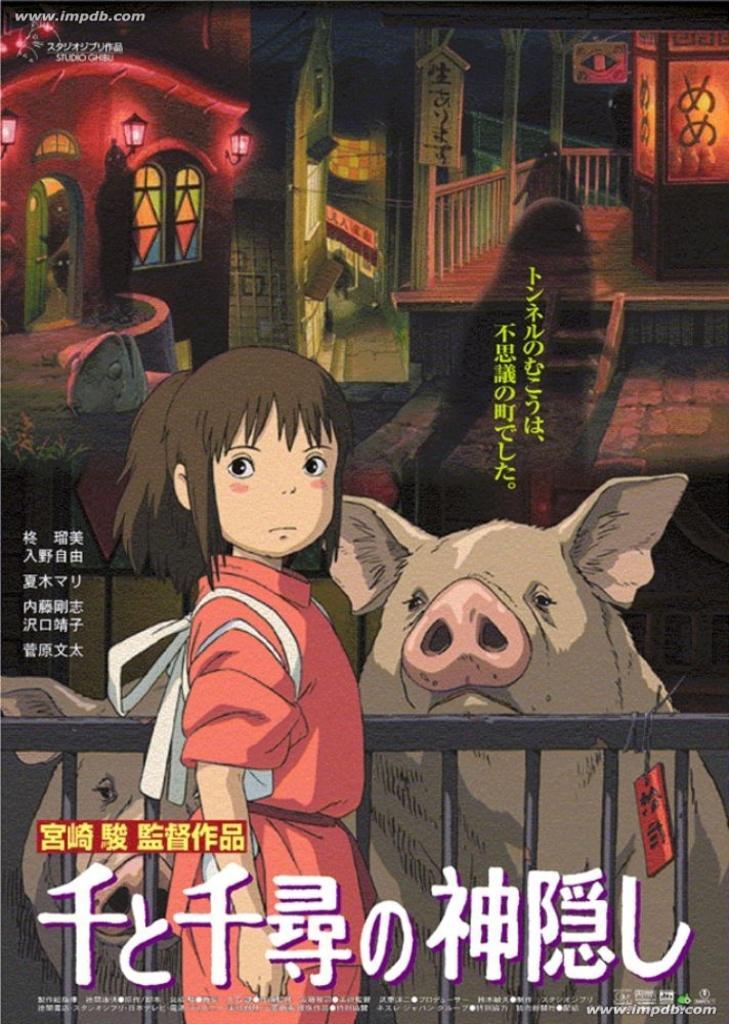Describe this image in one or two sentences. In this picture there is a kid standing and there is a fence wall beside her and there are two pigs on the another side of fence wall and there are some other objects in the background. 